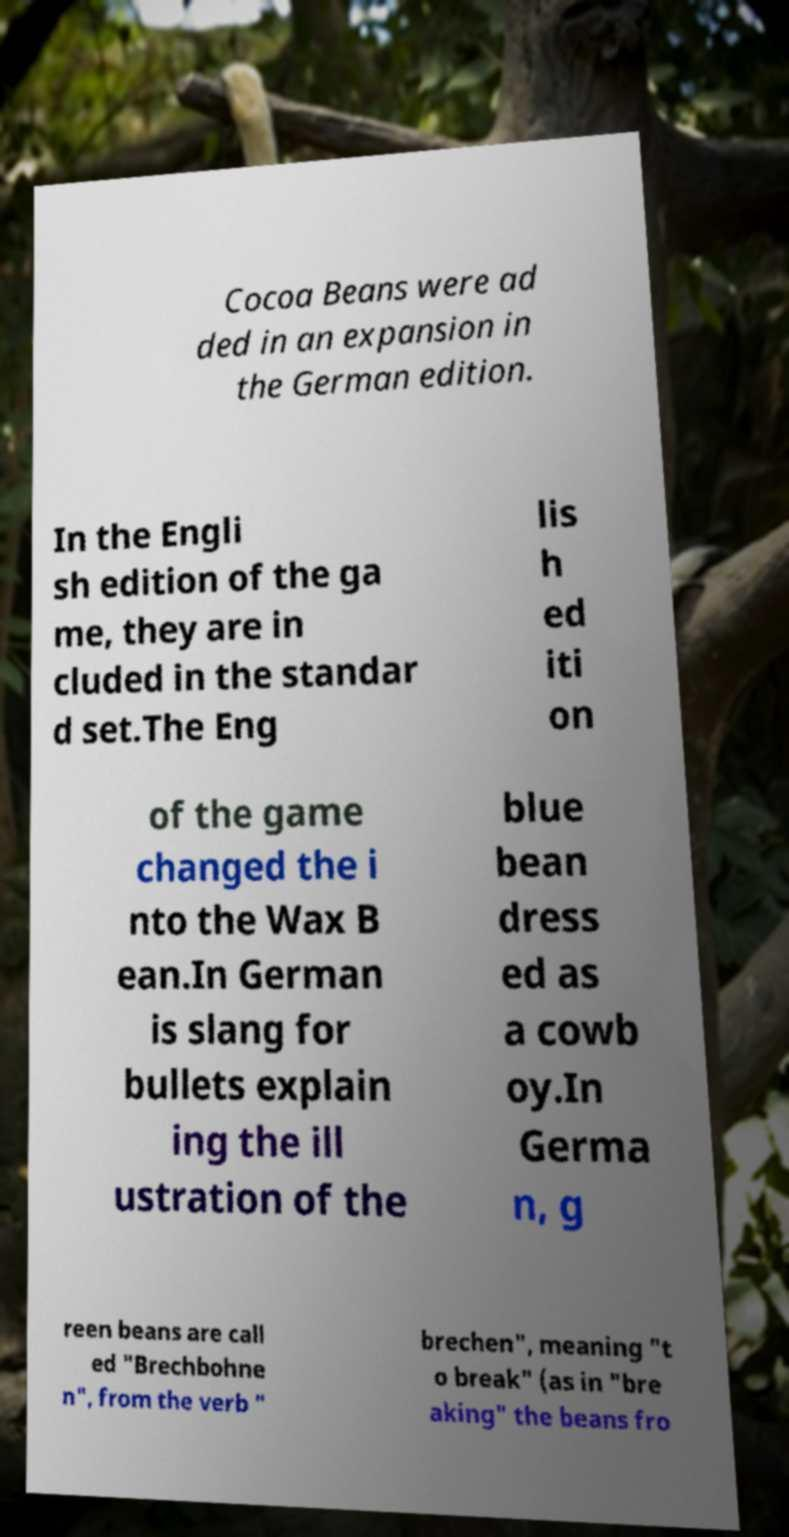Can you accurately transcribe the text from the provided image for me? Cocoa Beans were ad ded in an expansion in the German edition. In the Engli sh edition of the ga me, they are in cluded in the standar d set.The Eng lis h ed iti on of the game changed the i nto the Wax B ean.In German is slang for bullets explain ing the ill ustration of the blue bean dress ed as a cowb oy.In Germa n, g reen beans are call ed "Brechbohne n", from the verb " brechen", meaning "t o break" (as in "bre aking" the beans fro 